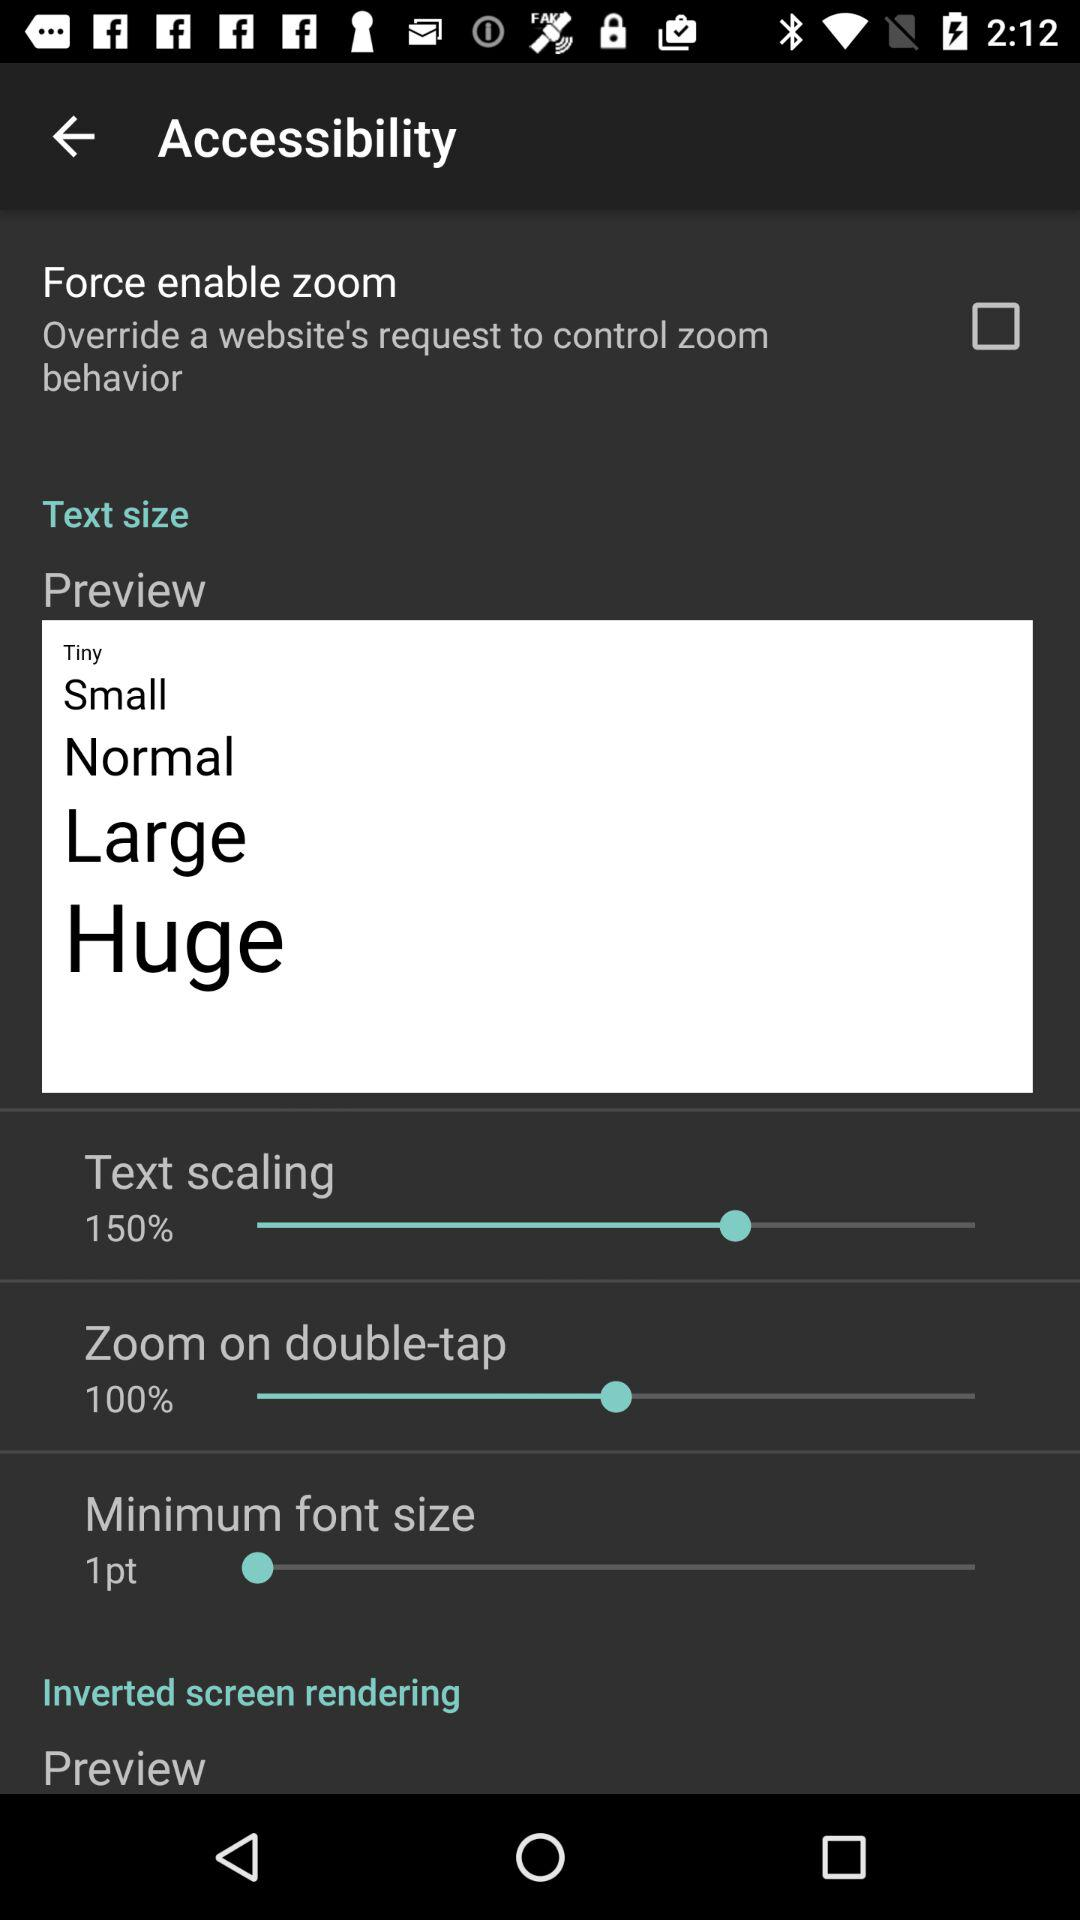What is the value selected for text scaling? The value selected for text scaling is 150%. 